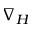<formula> <loc_0><loc_0><loc_500><loc_500>\nabla _ { H }</formula> 